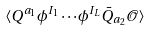<formula> <loc_0><loc_0><loc_500><loc_500>\langle Q ^ { a _ { 1 } } \phi ^ { I _ { 1 } } \cdots \phi ^ { I _ { L } } \bar { Q } _ { a _ { 2 } } \mathcal { O } \rangle</formula> 